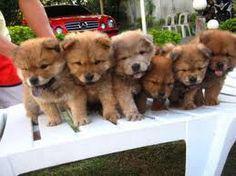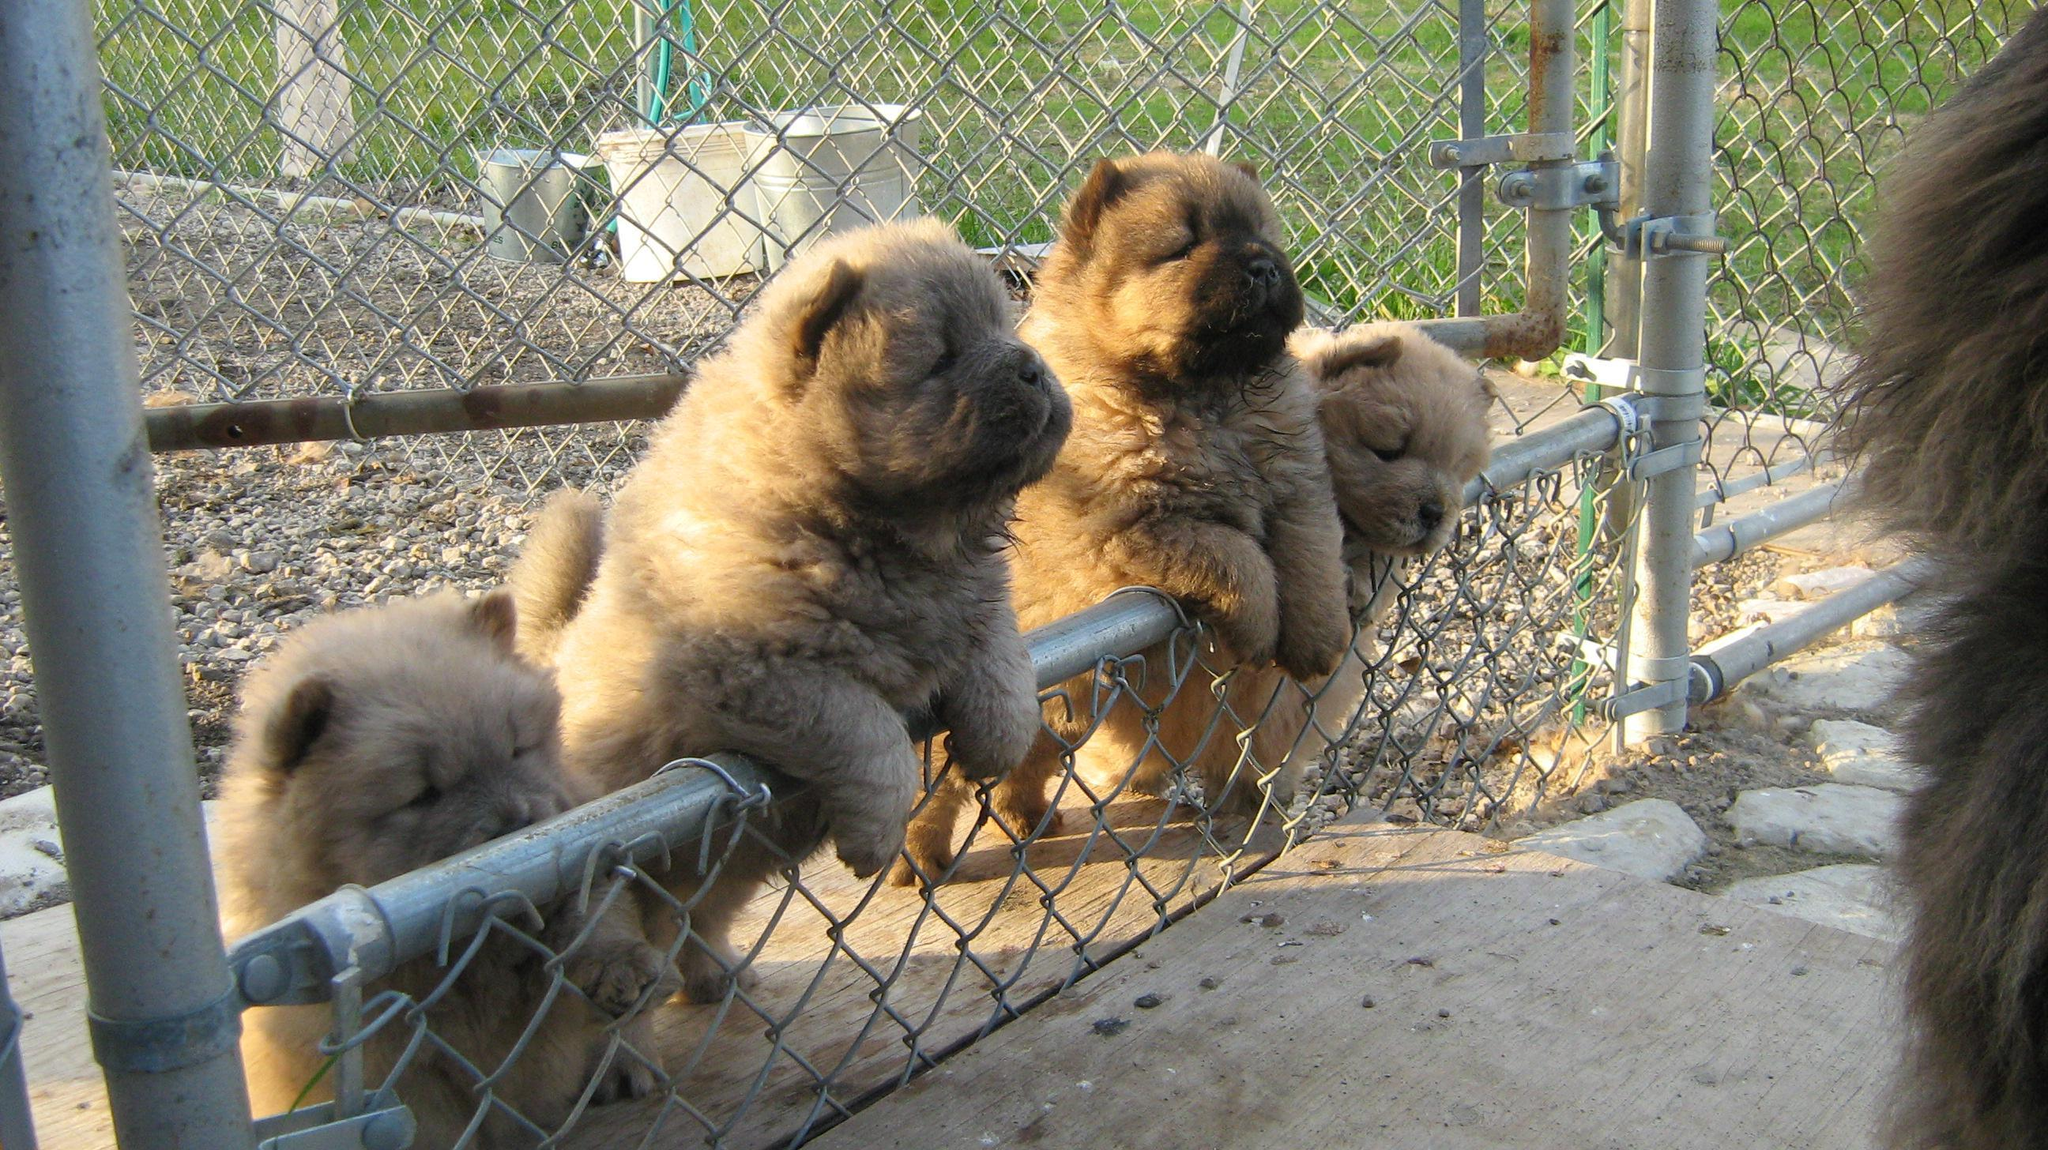The first image is the image on the left, the second image is the image on the right. Evaluate the accuracy of this statement regarding the images: "Some of the dogs are standing in a row.". Is it true? Answer yes or no. Yes. The first image is the image on the left, the second image is the image on the right. For the images displayed, is the sentence "All images show multiple chow puppies, and the left image contains at least five camera-facing puppies." factually correct? Answer yes or no. Yes. 